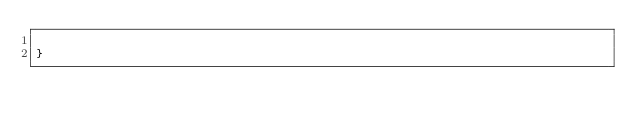<code> <loc_0><loc_0><loc_500><loc_500><_Java_>
}
</code> 